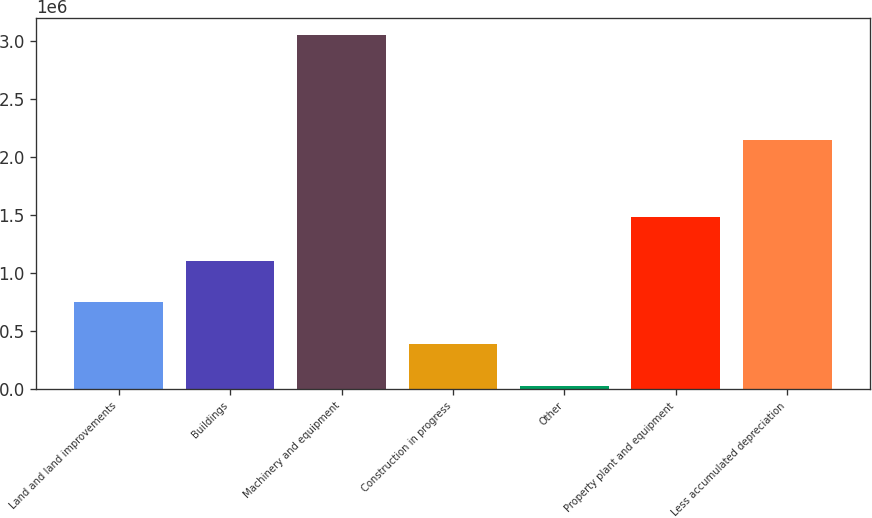<chart> <loc_0><loc_0><loc_500><loc_500><bar_chart><fcel>Land and land improvements<fcel>Buildings<fcel>Machinery and equipment<fcel>Construction in progress<fcel>Other<fcel>Property plant and equipment<fcel>Less accumulated depreciation<nl><fcel>745448<fcel>1.10459e+06<fcel>3.04514e+06<fcel>386309<fcel>27170<fcel>1.47665e+06<fcel>2.14191e+06<nl></chart> 